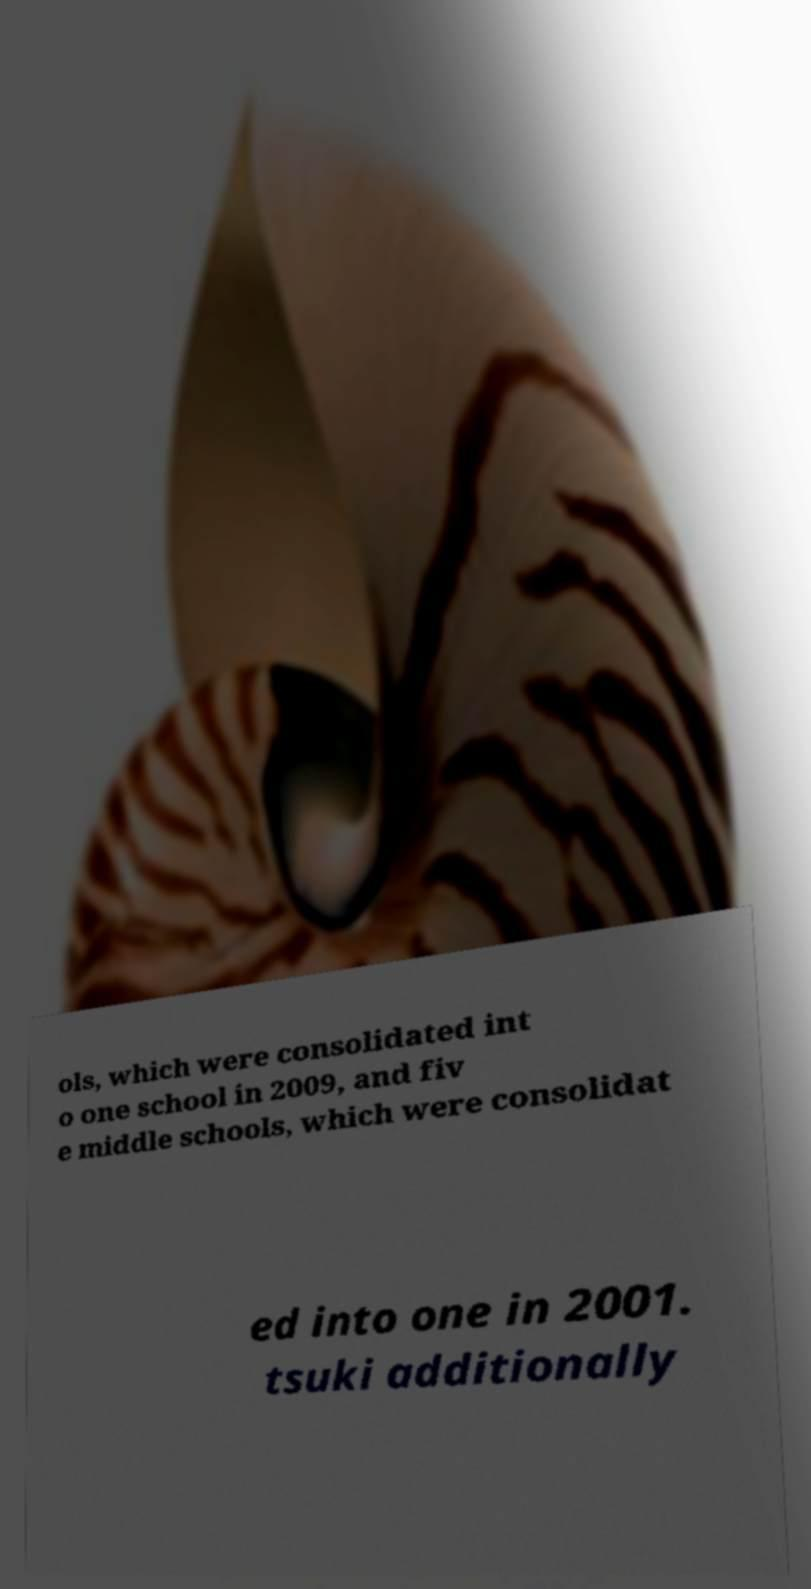There's text embedded in this image that I need extracted. Can you transcribe it verbatim? ols, which were consolidated int o one school in 2009, and fiv e middle schools, which were consolidat ed into one in 2001. tsuki additionally 